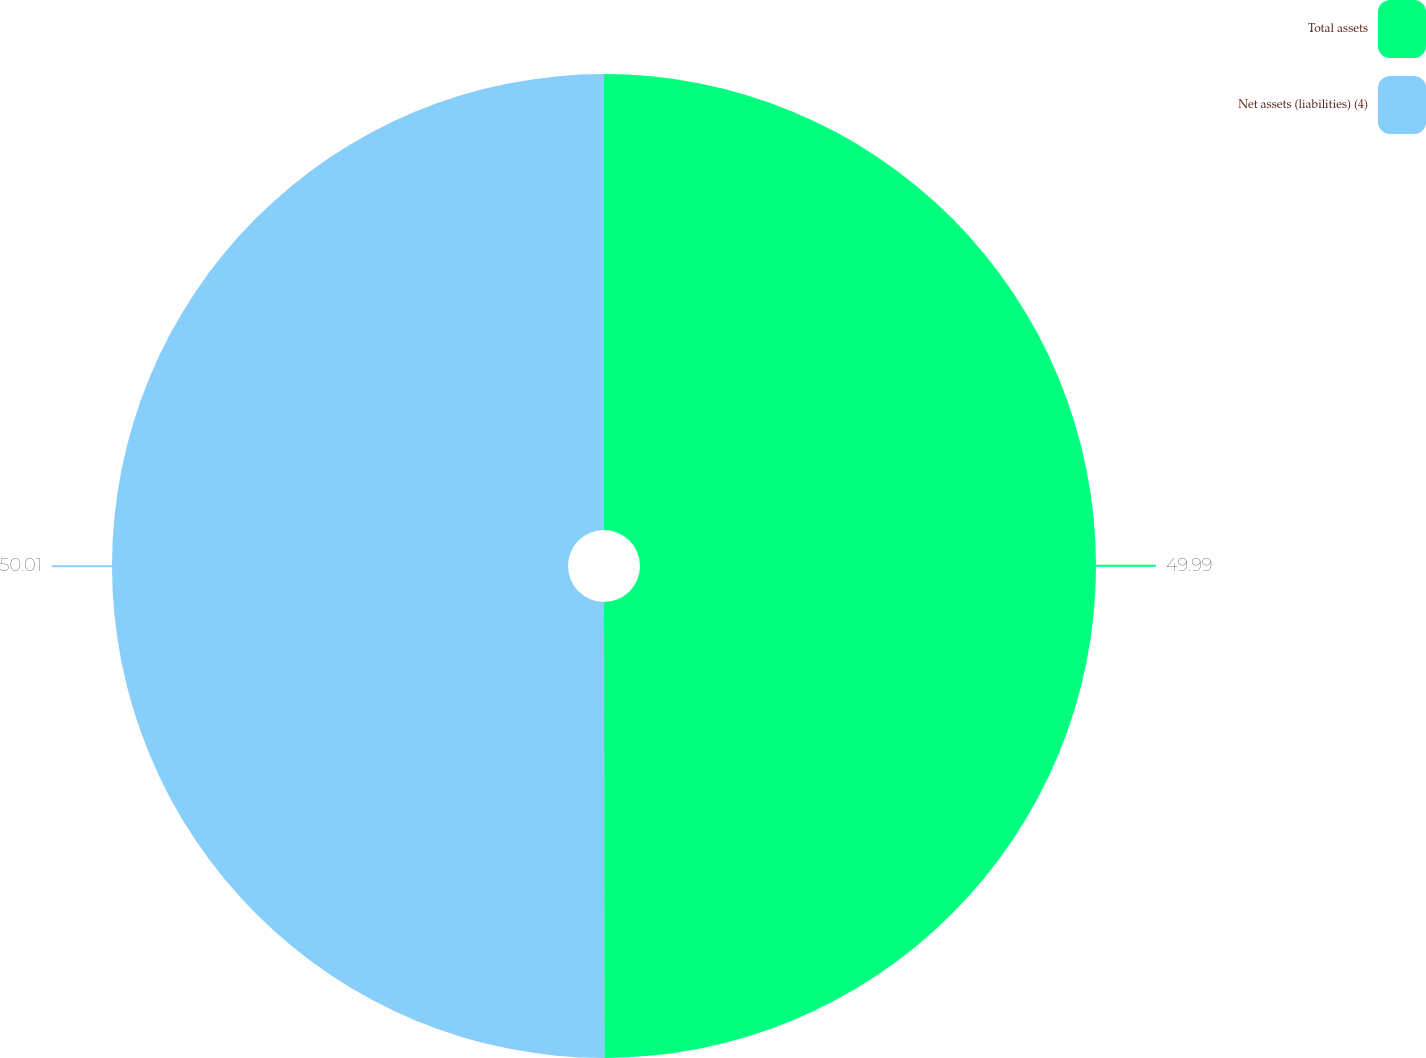Convert chart to OTSL. <chart><loc_0><loc_0><loc_500><loc_500><pie_chart><fcel>Total assets<fcel>Net assets (liabilities) (4)<nl><fcel>49.99%<fcel>50.01%<nl></chart> 